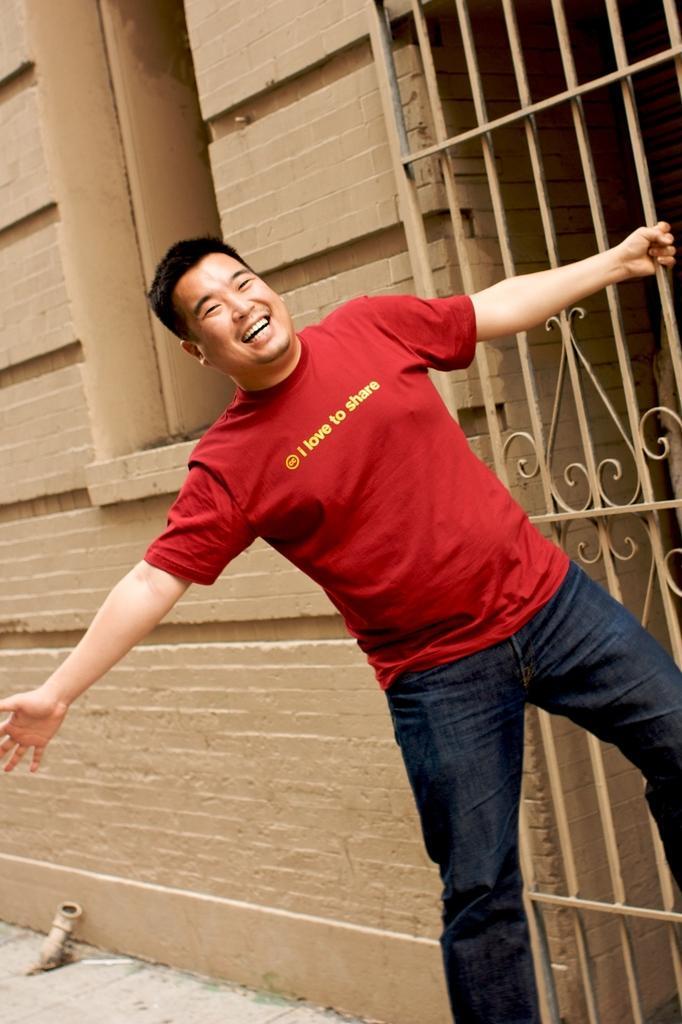Can you describe this image briefly? This picture shows a man standing holding a metal fence and we see smile on his face and red color t-shirt and we see a building. 